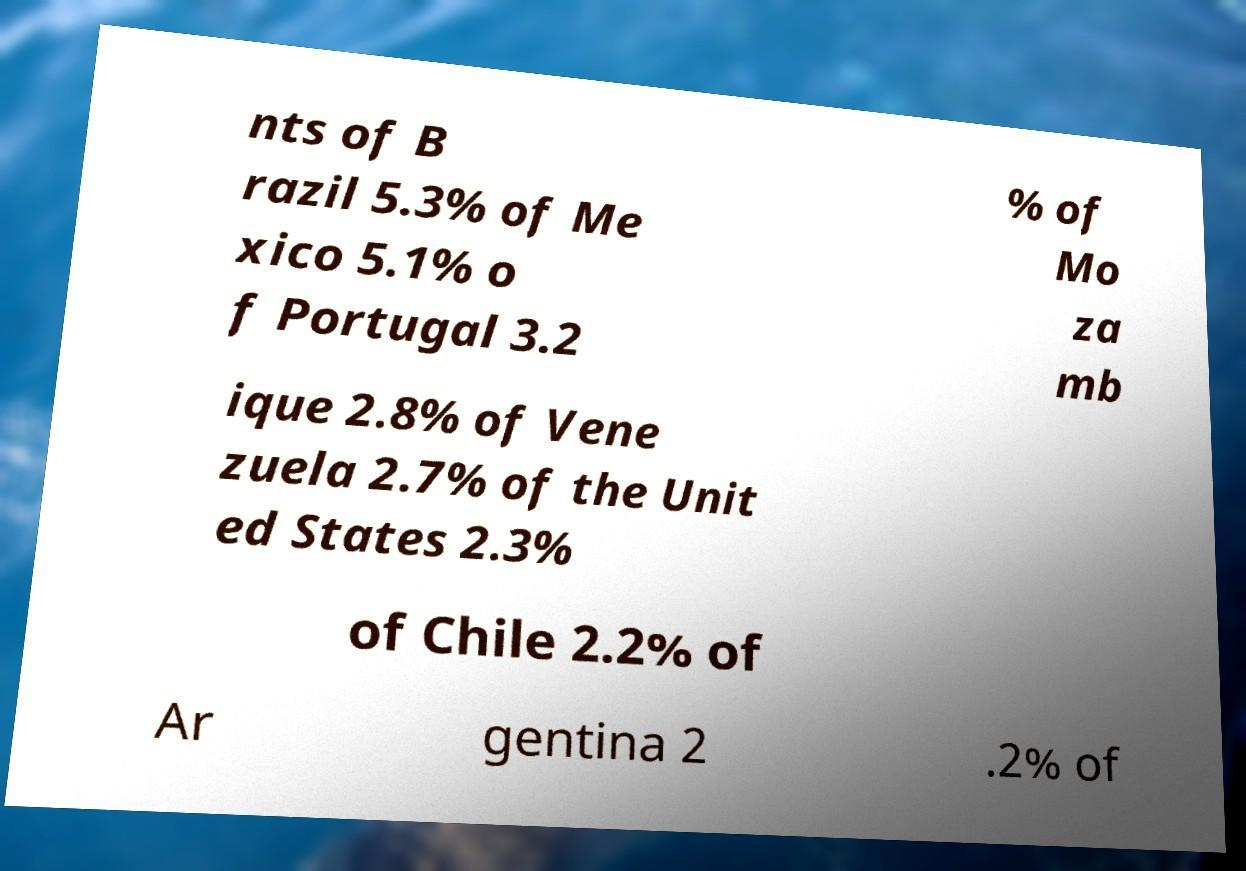There's text embedded in this image that I need extracted. Can you transcribe it verbatim? nts of B razil 5.3% of Me xico 5.1% o f Portugal 3.2 % of Mo za mb ique 2.8% of Vene zuela 2.7% of the Unit ed States 2.3% of Chile 2.2% of Ar gentina 2 .2% of 